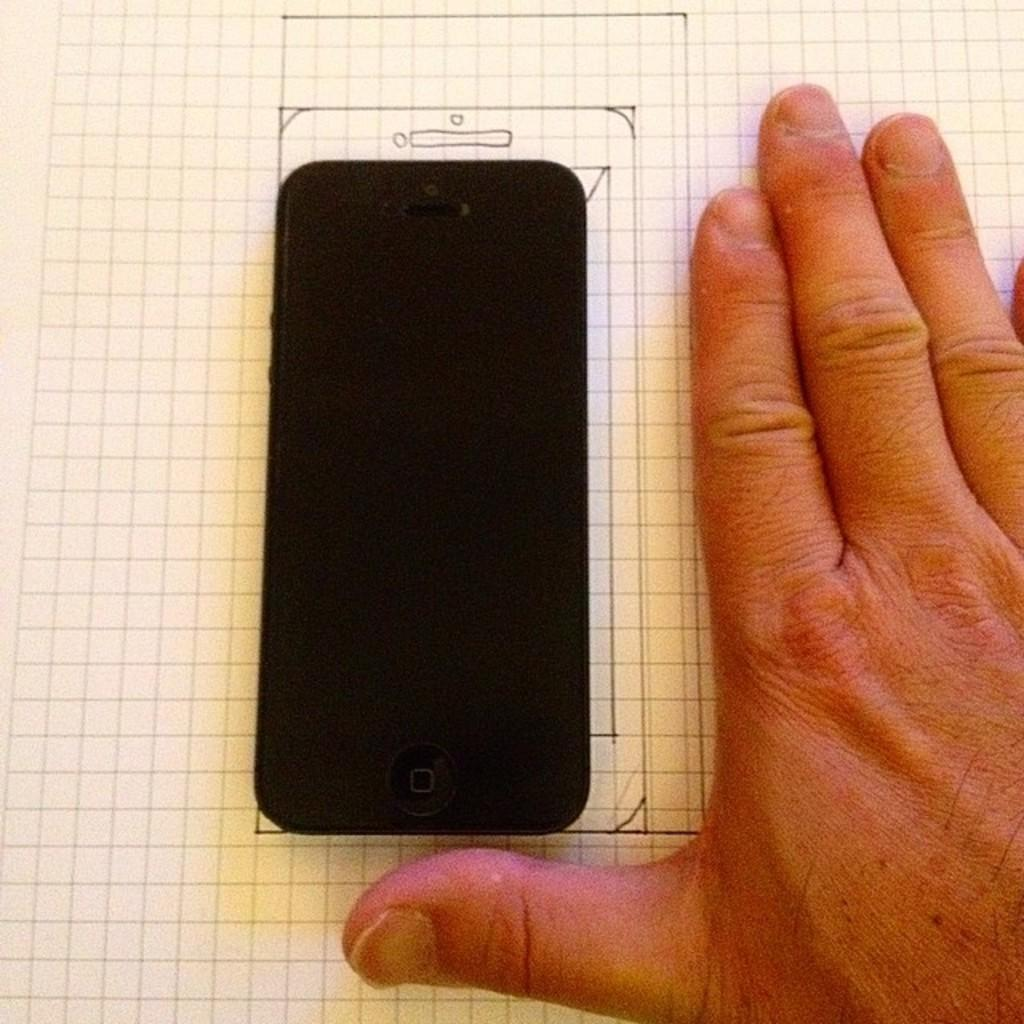What electronic device is present in the image? There is a mobile phone in the image. What is the mobile phone placed on? The mobile phone is on a paper. What is the color of the mobile phone? The mobile phone is black in color. What can be seen on the right side of the image? There is a hand of a human on the right side of the image. What type of example is being demonstrated with a knife in the image? There is no knife present in the image, and therefore no example is being demonstrated. 